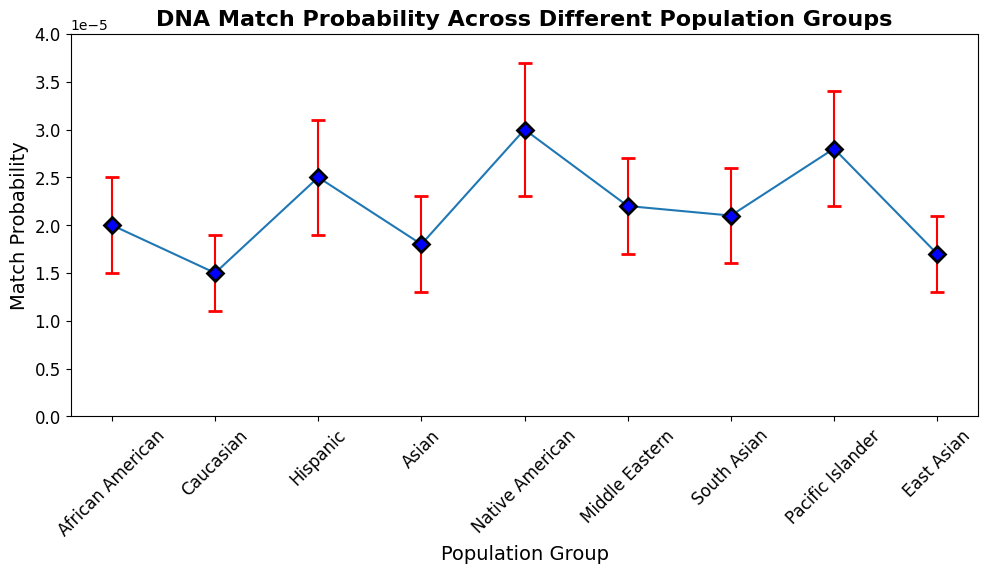Which population group has the highest match probability? By inspecting the y-values (match probabilities) of the error bars, we see that the Native American group has the highest match probability.
Answer: Native American What is the lowest match probability and which group does it belong to? Looking at the y-values of the error bars, the Caucasian group has the lowest match probability.
Answer: 0.000015, Caucasian Is the match probability for the Pacific Islander group greater than the South Asian group? By comparing the y-values of the Pacific Islander and South Asian groups, Pacific Islander has a higher match probability (0.000028) than South Asian (0.000021).
Answer: Yes Which groups have a match probability within the standard error range of 0.000020 to 0.000030? Checking each group's match probability and its standard error range, the groups within this range are Hispanic, Native American, Middle Eastern, South Asian, and Pacific Islander.
Answer: Hispanic, Native American, Middle Eastern, South Asian, Pacific Islander What is the difference in match probability between the group with the highest value and the group with the lowest value? The highest match probability is 0.000030 (Native American), and the lowest is 0.000015 (Caucasian). The difference is calculated as 0.000030 - 0.000015.
Answer: 0.000015 What is the average match probability of all the groups? Sum the match probabilities of all groups and divide by the total number of groups: (0.00002 + 0.000015 + 0.000025 + 0.000018 + 0.000030 + 0.000022 + 0.000021 + 0.000028 + 0.000017)/9.
Answer: 0.00002286 Looking at the match probabilities, which two population groups have the closest values? By comparing the match probabilities of all groups, African American (0.00002) and South Asian (0.000021) have the closest values.
Answer: African American, South Asian Are any match probabilities equal within the error margins? For each pair of groups, check if their match probabilities overlap within the range of their error bars. The overlap occurs between several groups like South Asian and Middle Eastern.
Answer: Yes Which population group has the largest standard error? By inspecting the error bars' vertical length, Native American has the largest standard error (0.000007).
Answer: Native American 